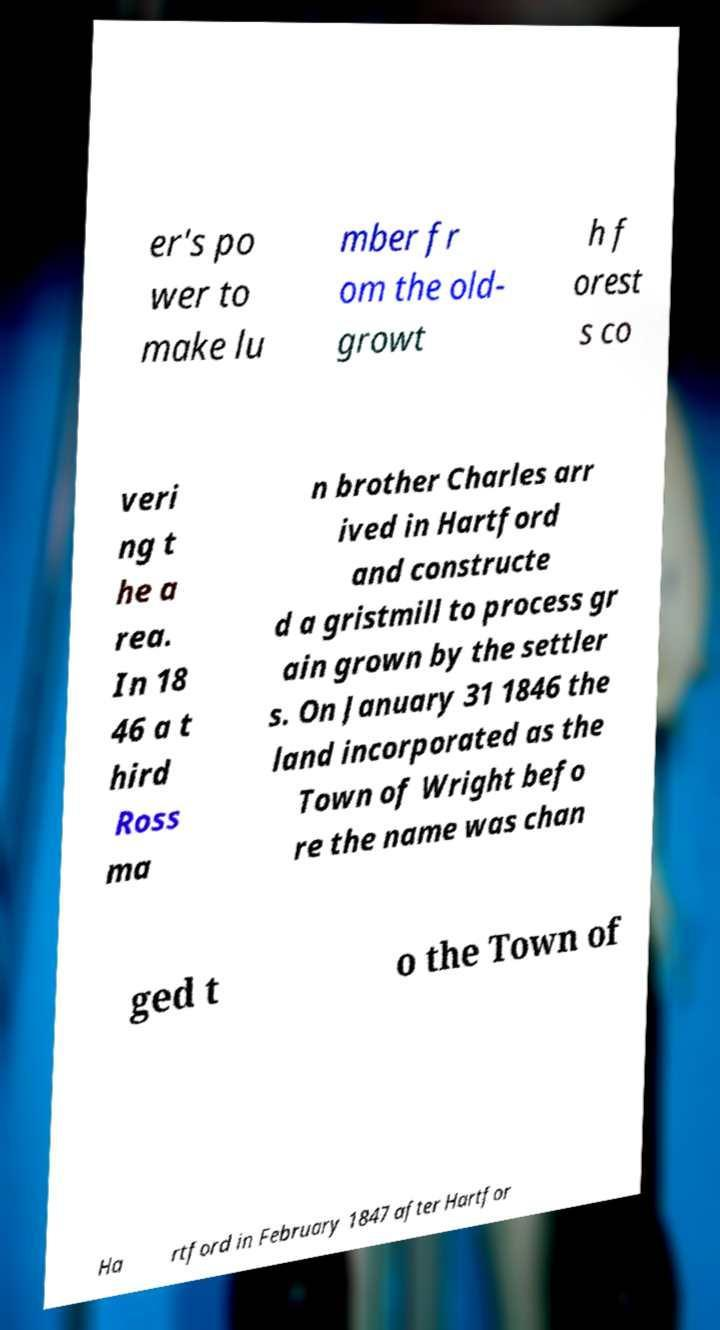For documentation purposes, I need the text within this image transcribed. Could you provide that? er's po wer to make lu mber fr om the old- growt h f orest s co veri ng t he a rea. In 18 46 a t hird Ross ma n brother Charles arr ived in Hartford and constructe d a gristmill to process gr ain grown by the settler s. On January 31 1846 the land incorporated as the Town of Wright befo re the name was chan ged t o the Town of Ha rtford in February 1847 after Hartfor 